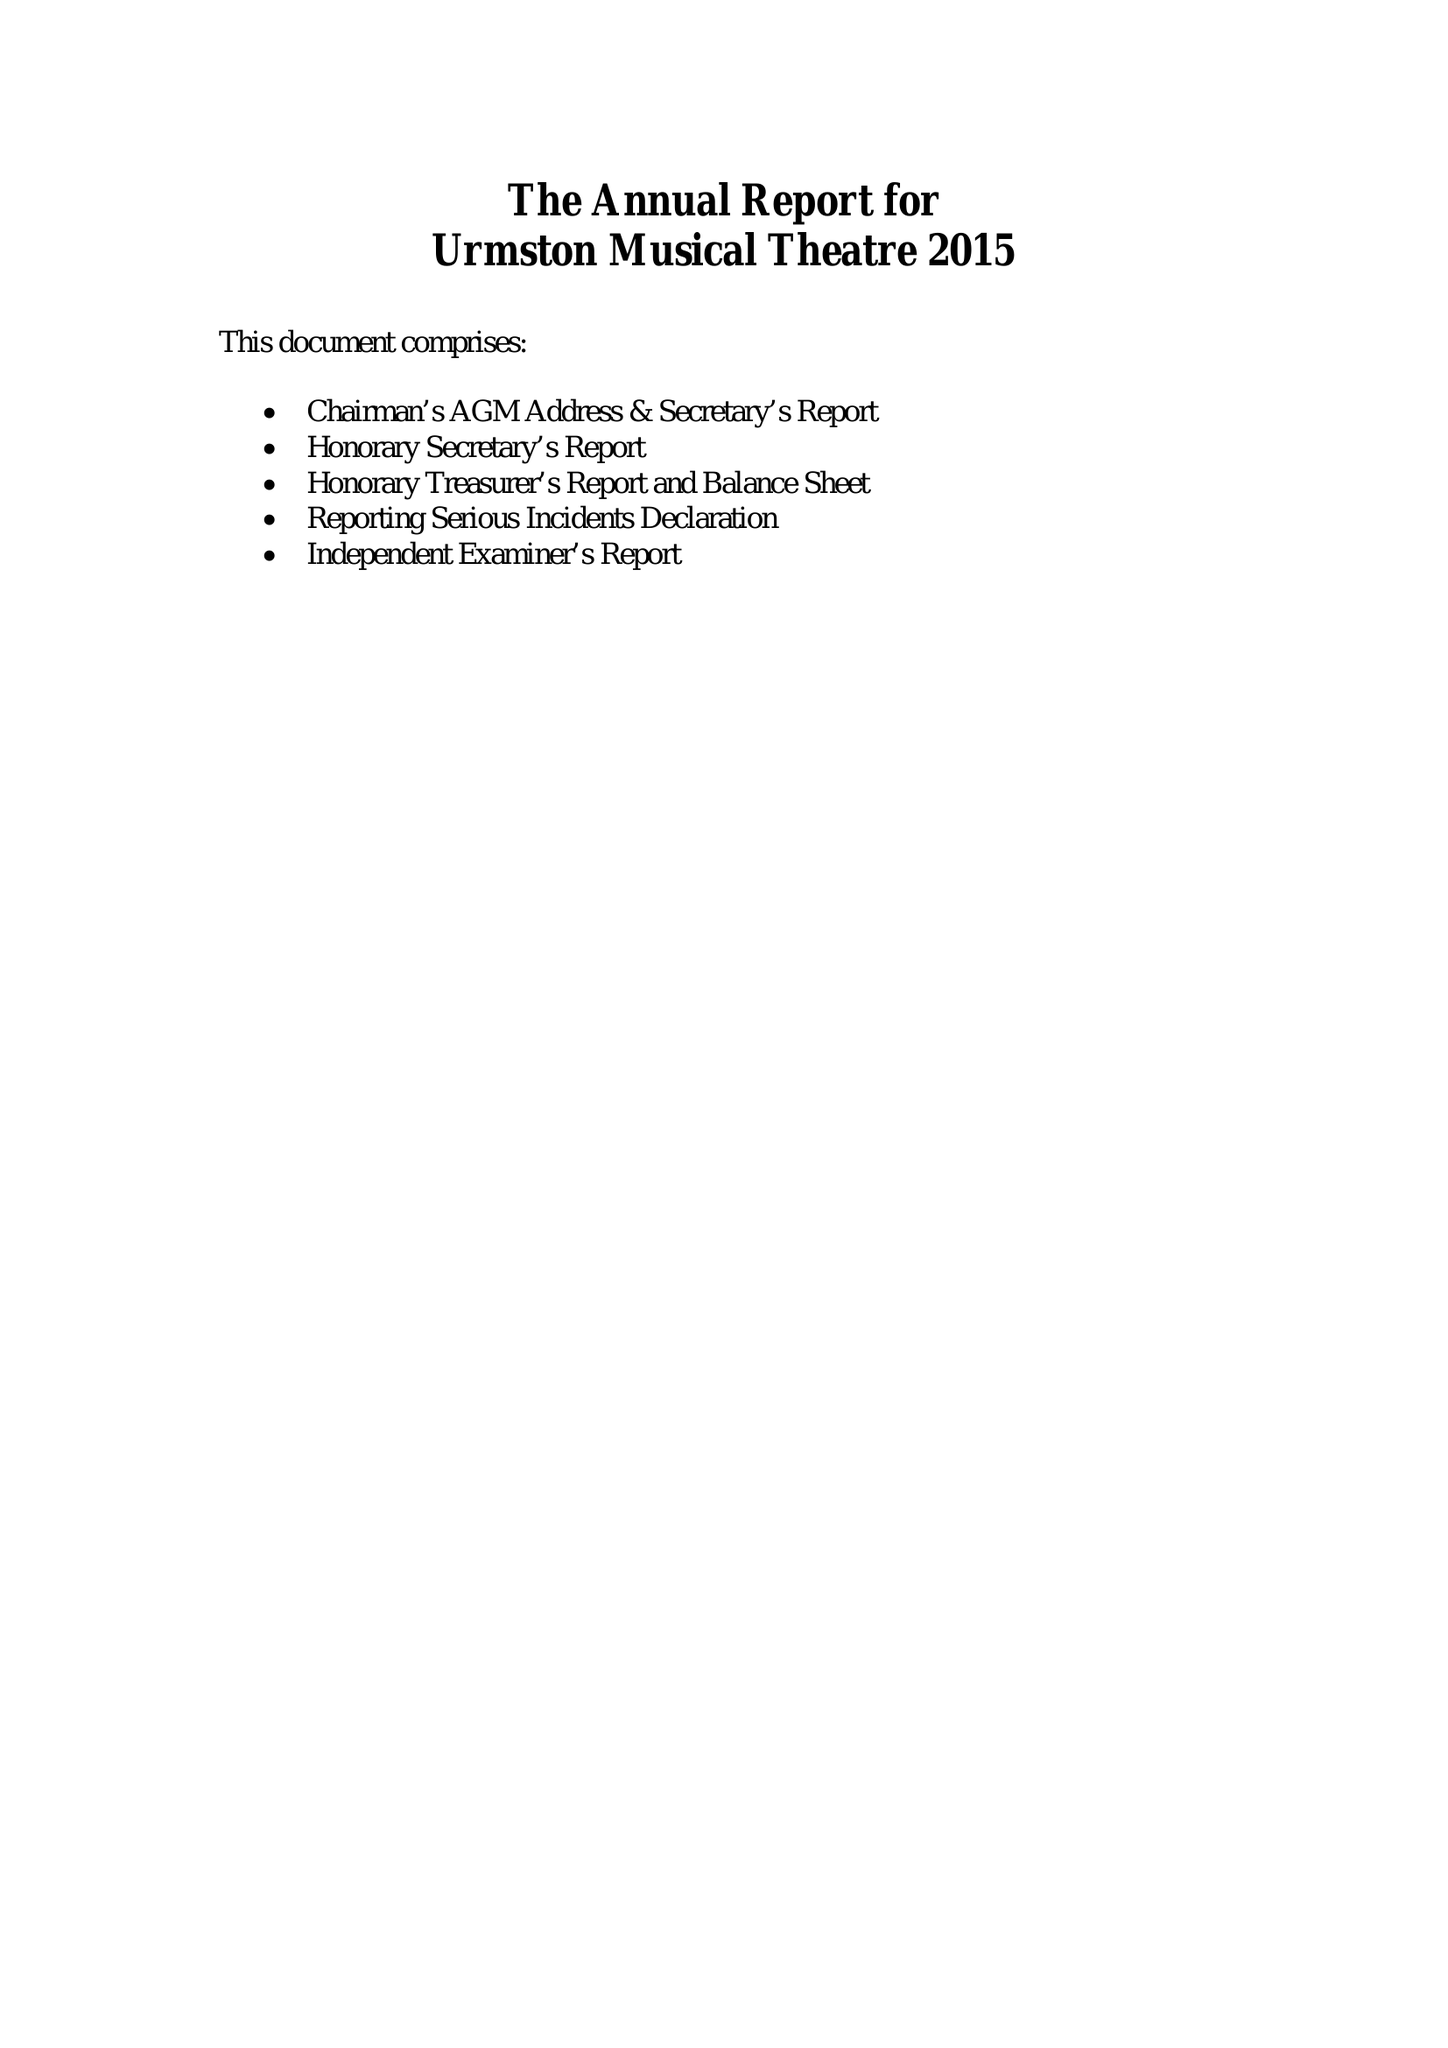What is the value for the income_annually_in_british_pounds?
Answer the question using a single word or phrase. 27842.00 